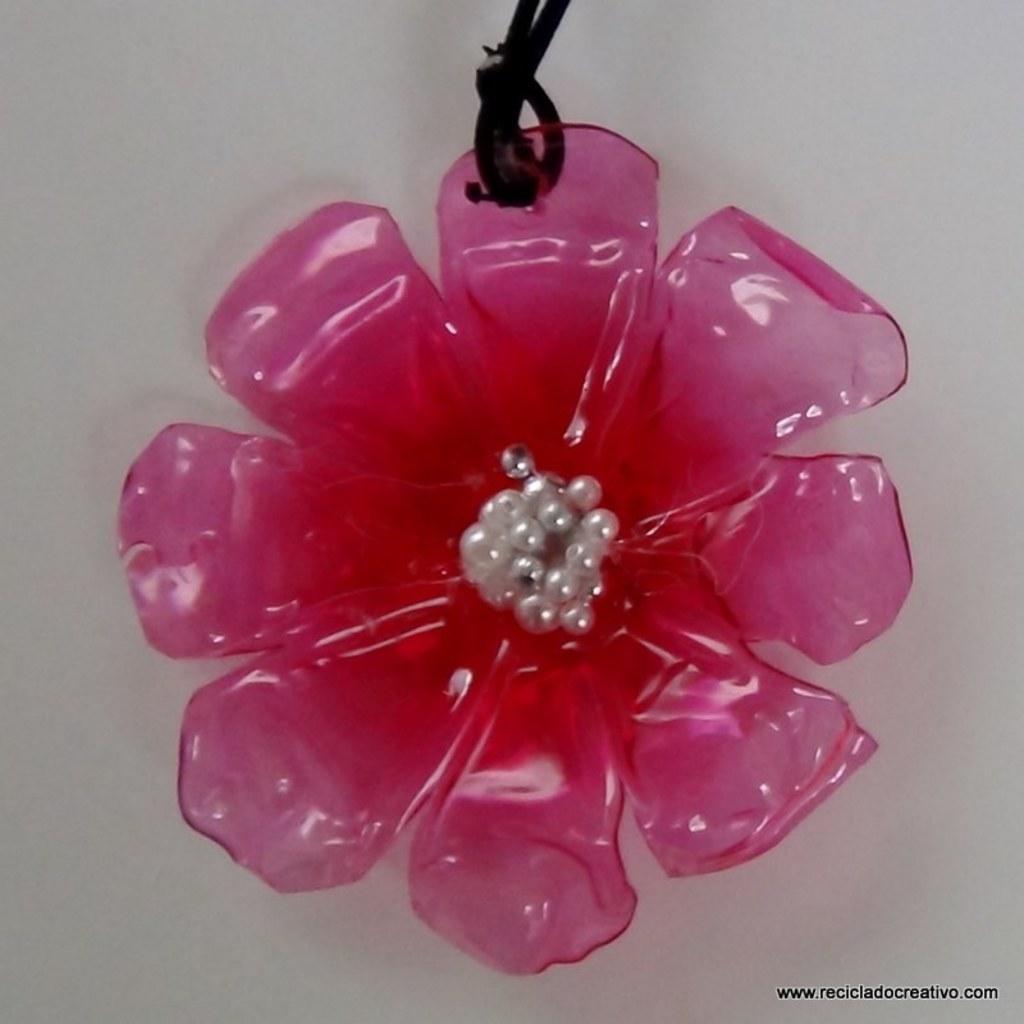Please provide a concise description of this image. As we can see in the image there is a plastic flower and wall. 